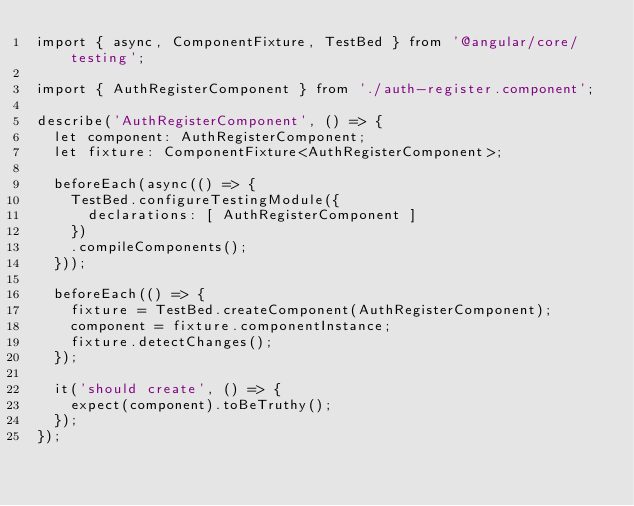<code> <loc_0><loc_0><loc_500><loc_500><_TypeScript_>import { async, ComponentFixture, TestBed } from '@angular/core/testing';

import { AuthRegisterComponent } from './auth-register.component';

describe('AuthRegisterComponent', () => {
  let component: AuthRegisterComponent;
  let fixture: ComponentFixture<AuthRegisterComponent>;

  beforeEach(async(() => {
    TestBed.configureTestingModule({
      declarations: [ AuthRegisterComponent ]
    })
    .compileComponents();
  }));

  beforeEach(() => {
    fixture = TestBed.createComponent(AuthRegisterComponent);
    component = fixture.componentInstance;
    fixture.detectChanges();
  });

  it('should create', () => {
    expect(component).toBeTruthy();
  });
});
</code> 